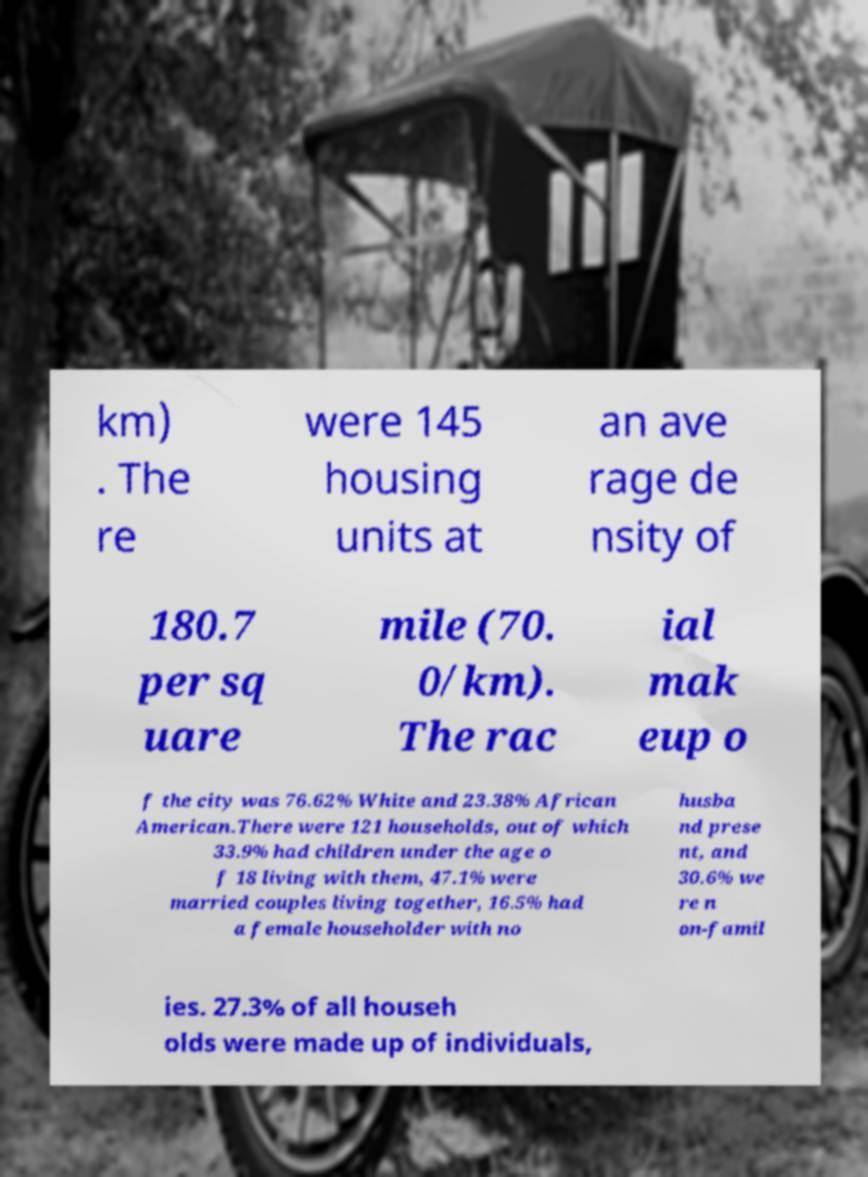Can you accurately transcribe the text from the provided image for me? km) . The re were 145 housing units at an ave rage de nsity of 180.7 per sq uare mile (70. 0/km). The rac ial mak eup o f the city was 76.62% White and 23.38% African American.There were 121 households, out of which 33.9% had children under the age o f 18 living with them, 47.1% were married couples living together, 16.5% had a female householder with no husba nd prese nt, and 30.6% we re n on-famil ies. 27.3% of all househ olds were made up of individuals, 